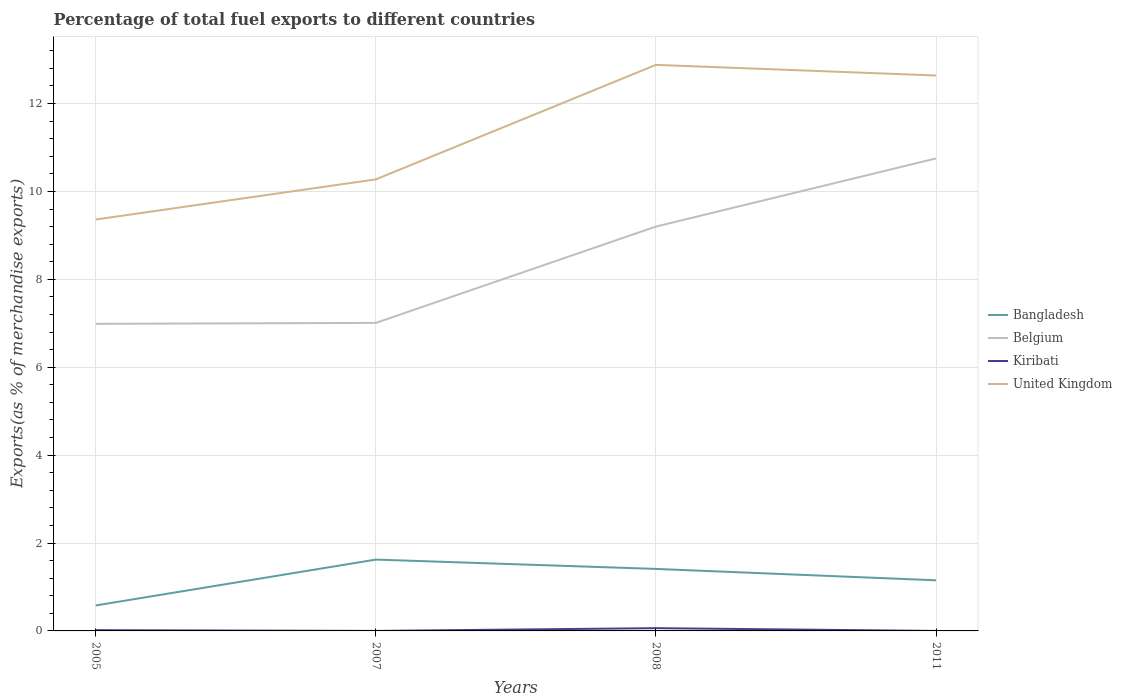How many different coloured lines are there?
Ensure brevity in your answer.  4. Is the number of lines equal to the number of legend labels?
Your answer should be compact. Yes. Across all years, what is the maximum percentage of exports to different countries in Bangladesh?
Your answer should be very brief. 0.58. What is the total percentage of exports to different countries in United Kingdom in the graph?
Your answer should be compact. -3.52. What is the difference between the highest and the second highest percentage of exports to different countries in Kiribati?
Ensure brevity in your answer.  0.06. What is the difference between the highest and the lowest percentage of exports to different countries in Bangladesh?
Your response must be concise. 2. How many lines are there?
Your answer should be very brief. 4. How many years are there in the graph?
Make the answer very short. 4. Are the values on the major ticks of Y-axis written in scientific E-notation?
Keep it short and to the point. No. Does the graph contain grids?
Give a very brief answer. Yes. What is the title of the graph?
Provide a succinct answer. Percentage of total fuel exports to different countries. What is the label or title of the Y-axis?
Provide a short and direct response. Exports(as % of merchandise exports). What is the Exports(as % of merchandise exports) in Bangladesh in 2005?
Your response must be concise. 0.58. What is the Exports(as % of merchandise exports) of Belgium in 2005?
Make the answer very short. 6.99. What is the Exports(as % of merchandise exports) of Kiribati in 2005?
Give a very brief answer. 0.02. What is the Exports(as % of merchandise exports) of United Kingdom in 2005?
Your answer should be very brief. 9.36. What is the Exports(as % of merchandise exports) of Bangladesh in 2007?
Your answer should be very brief. 1.62. What is the Exports(as % of merchandise exports) of Belgium in 2007?
Offer a very short reply. 7.01. What is the Exports(as % of merchandise exports) of Kiribati in 2007?
Offer a terse response. 0. What is the Exports(as % of merchandise exports) in United Kingdom in 2007?
Ensure brevity in your answer.  10.27. What is the Exports(as % of merchandise exports) of Bangladesh in 2008?
Offer a very short reply. 1.41. What is the Exports(as % of merchandise exports) in Belgium in 2008?
Your answer should be compact. 9.2. What is the Exports(as % of merchandise exports) in Kiribati in 2008?
Provide a succinct answer. 0.06. What is the Exports(as % of merchandise exports) of United Kingdom in 2008?
Your answer should be very brief. 12.88. What is the Exports(as % of merchandise exports) of Bangladesh in 2011?
Provide a succinct answer. 1.15. What is the Exports(as % of merchandise exports) in Belgium in 2011?
Provide a short and direct response. 10.75. What is the Exports(as % of merchandise exports) in Kiribati in 2011?
Ensure brevity in your answer.  0. What is the Exports(as % of merchandise exports) in United Kingdom in 2011?
Make the answer very short. 12.64. Across all years, what is the maximum Exports(as % of merchandise exports) in Bangladesh?
Your answer should be compact. 1.62. Across all years, what is the maximum Exports(as % of merchandise exports) in Belgium?
Your response must be concise. 10.75. Across all years, what is the maximum Exports(as % of merchandise exports) of Kiribati?
Keep it short and to the point. 0.06. Across all years, what is the maximum Exports(as % of merchandise exports) of United Kingdom?
Provide a short and direct response. 12.88. Across all years, what is the minimum Exports(as % of merchandise exports) in Bangladesh?
Give a very brief answer. 0.58. Across all years, what is the minimum Exports(as % of merchandise exports) of Belgium?
Give a very brief answer. 6.99. Across all years, what is the minimum Exports(as % of merchandise exports) of Kiribati?
Ensure brevity in your answer.  0. Across all years, what is the minimum Exports(as % of merchandise exports) in United Kingdom?
Ensure brevity in your answer.  9.36. What is the total Exports(as % of merchandise exports) in Bangladesh in the graph?
Give a very brief answer. 4.77. What is the total Exports(as % of merchandise exports) of Belgium in the graph?
Offer a very short reply. 33.95. What is the total Exports(as % of merchandise exports) of Kiribati in the graph?
Ensure brevity in your answer.  0.08. What is the total Exports(as % of merchandise exports) of United Kingdom in the graph?
Give a very brief answer. 45.15. What is the difference between the Exports(as % of merchandise exports) in Bangladesh in 2005 and that in 2007?
Offer a very short reply. -1.04. What is the difference between the Exports(as % of merchandise exports) of Belgium in 2005 and that in 2007?
Your answer should be very brief. -0.02. What is the difference between the Exports(as % of merchandise exports) of Kiribati in 2005 and that in 2007?
Your answer should be very brief. 0.02. What is the difference between the Exports(as % of merchandise exports) of United Kingdom in 2005 and that in 2007?
Offer a terse response. -0.91. What is the difference between the Exports(as % of merchandise exports) of Bangladesh in 2005 and that in 2008?
Offer a very short reply. -0.83. What is the difference between the Exports(as % of merchandise exports) in Belgium in 2005 and that in 2008?
Provide a succinct answer. -2.21. What is the difference between the Exports(as % of merchandise exports) of Kiribati in 2005 and that in 2008?
Your answer should be very brief. -0.05. What is the difference between the Exports(as % of merchandise exports) of United Kingdom in 2005 and that in 2008?
Your answer should be compact. -3.52. What is the difference between the Exports(as % of merchandise exports) in Bangladesh in 2005 and that in 2011?
Your answer should be very brief. -0.57. What is the difference between the Exports(as % of merchandise exports) of Belgium in 2005 and that in 2011?
Provide a short and direct response. -3.76. What is the difference between the Exports(as % of merchandise exports) in Kiribati in 2005 and that in 2011?
Offer a very short reply. 0.02. What is the difference between the Exports(as % of merchandise exports) of United Kingdom in 2005 and that in 2011?
Keep it short and to the point. -3.28. What is the difference between the Exports(as % of merchandise exports) in Bangladesh in 2007 and that in 2008?
Your answer should be compact. 0.21. What is the difference between the Exports(as % of merchandise exports) of Belgium in 2007 and that in 2008?
Your response must be concise. -2.19. What is the difference between the Exports(as % of merchandise exports) of Kiribati in 2007 and that in 2008?
Your response must be concise. -0.06. What is the difference between the Exports(as % of merchandise exports) of United Kingdom in 2007 and that in 2008?
Ensure brevity in your answer.  -2.61. What is the difference between the Exports(as % of merchandise exports) of Bangladesh in 2007 and that in 2011?
Offer a very short reply. 0.47. What is the difference between the Exports(as % of merchandise exports) of Belgium in 2007 and that in 2011?
Offer a terse response. -3.74. What is the difference between the Exports(as % of merchandise exports) of Kiribati in 2007 and that in 2011?
Provide a succinct answer. 0. What is the difference between the Exports(as % of merchandise exports) in United Kingdom in 2007 and that in 2011?
Provide a short and direct response. -2.36. What is the difference between the Exports(as % of merchandise exports) in Bangladesh in 2008 and that in 2011?
Offer a very short reply. 0.26. What is the difference between the Exports(as % of merchandise exports) in Belgium in 2008 and that in 2011?
Your answer should be very brief. -1.55. What is the difference between the Exports(as % of merchandise exports) of Kiribati in 2008 and that in 2011?
Provide a short and direct response. 0.06. What is the difference between the Exports(as % of merchandise exports) of United Kingdom in 2008 and that in 2011?
Offer a terse response. 0.24. What is the difference between the Exports(as % of merchandise exports) of Bangladesh in 2005 and the Exports(as % of merchandise exports) of Belgium in 2007?
Ensure brevity in your answer.  -6.43. What is the difference between the Exports(as % of merchandise exports) of Bangladesh in 2005 and the Exports(as % of merchandise exports) of Kiribati in 2007?
Ensure brevity in your answer.  0.58. What is the difference between the Exports(as % of merchandise exports) in Bangladesh in 2005 and the Exports(as % of merchandise exports) in United Kingdom in 2007?
Offer a very short reply. -9.7. What is the difference between the Exports(as % of merchandise exports) of Belgium in 2005 and the Exports(as % of merchandise exports) of Kiribati in 2007?
Give a very brief answer. 6.99. What is the difference between the Exports(as % of merchandise exports) of Belgium in 2005 and the Exports(as % of merchandise exports) of United Kingdom in 2007?
Make the answer very short. -3.29. What is the difference between the Exports(as % of merchandise exports) of Kiribati in 2005 and the Exports(as % of merchandise exports) of United Kingdom in 2007?
Your response must be concise. -10.26. What is the difference between the Exports(as % of merchandise exports) in Bangladesh in 2005 and the Exports(as % of merchandise exports) in Belgium in 2008?
Keep it short and to the point. -8.62. What is the difference between the Exports(as % of merchandise exports) of Bangladesh in 2005 and the Exports(as % of merchandise exports) of Kiribati in 2008?
Offer a very short reply. 0.52. What is the difference between the Exports(as % of merchandise exports) in Bangladesh in 2005 and the Exports(as % of merchandise exports) in United Kingdom in 2008?
Keep it short and to the point. -12.3. What is the difference between the Exports(as % of merchandise exports) of Belgium in 2005 and the Exports(as % of merchandise exports) of Kiribati in 2008?
Provide a succinct answer. 6.92. What is the difference between the Exports(as % of merchandise exports) in Belgium in 2005 and the Exports(as % of merchandise exports) in United Kingdom in 2008?
Give a very brief answer. -5.89. What is the difference between the Exports(as % of merchandise exports) of Kiribati in 2005 and the Exports(as % of merchandise exports) of United Kingdom in 2008?
Ensure brevity in your answer.  -12.86. What is the difference between the Exports(as % of merchandise exports) in Bangladesh in 2005 and the Exports(as % of merchandise exports) in Belgium in 2011?
Your answer should be very brief. -10.17. What is the difference between the Exports(as % of merchandise exports) in Bangladesh in 2005 and the Exports(as % of merchandise exports) in Kiribati in 2011?
Ensure brevity in your answer.  0.58. What is the difference between the Exports(as % of merchandise exports) in Bangladesh in 2005 and the Exports(as % of merchandise exports) in United Kingdom in 2011?
Your response must be concise. -12.06. What is the difference between the Exports(as % of merchandise exports) in Belgium in 2005 and the Exports(as % of merchandise exports) in Kiribati in 2011?
Provide a succinct answer. 6.99. What is the difference between the Exports(as % of merchandise exports) in Belgium in 2005 and the Exports(as % of merchandise exports) in United Kingdom in 2011?
Offer a very short reply. -5.65. What is the difference between the Exports(as % of merchandise exports) of Kiribati in 2005 and the Exports(as % of merchandise exports) of United Kingdom in 2011?
Your response must be concise. -12.62. What is the difference between the Exports(as % of merchandise exports) in Bangladesh in 2007 and the Exports(as % of merchandise exports) in Belgium in 2008?
Your answer should be very brief. -7.58. What is the difference between the Exports(as % of merchandise exports) of Bangladesh in 2007 and the Exports(as % of merchandise exports) of Kiribati in 2008?
Provide a short and direct response. 1.56. What is the difference between the Exports(as % of merchandise exports) in Bangladesh in 2007 and the Exports(as % of merchandise exports) in United Kingdom in 2008?
Keep it short and to the point. -11.26. What is the difference between the Exports(as % of merchandise exports) of Belgium in 2007 and the Exports(as % of merchandise exports) of Kiribati in 2008?
Provide a succinct answer. 6.95. What is the difference between the Exports(as % of merchandise exports) of Belgium in 2007 and the Exports(as % of merchandise exports) of United Kingdom in 2008?
Your answer should be very brief. -5.87. What is the difference between the Exports(as % of merchandise exports) in Kiribati in 2007 and the Exports(as % of merchandise exports) in United Kingdom in 2008?
Make the answer very short. -12.88. What is the difference between the Exports(as % of merchandise exports) in Bangladesh in 2007 and the Exports(as % of merchandise exports) in Belgium in 2011?
Your answer should be compact. -9.13. What is the difference between the Exports(as % of merchandise exports) of Bangladesh in 2007 and the Exports(as % of merchandise exports) of Kiribati in 2011?
Keep it short and to the point. 1.62. What is the difference between the Exports(as % of merchandise exports) in Bangladesh in 2007 and the Exports(as % of merchandise exports) in United Kingdom in 2011?
Provide a succinct answer. -11.02. What is the difference between the Exports(as % of merchandise exports) of Belgium in 2007 and the Exports(as % of merchandise exports) of Kiribati in 2011?
Give a very brief answer. 7.01. What is the difference between the Exports(as % of merchandise exports) of Belgium in 2007 and the Exports(as % of merchandise exports) of United Kingdom in 2011?
Offer a terse response. -5.63. What is the difference between the Exports(as % of merchandise exports) in Kiribati in 2007 and the Exports(as % of merchandise exports) in United Kingdom in 2011?
Offer a terse response. -12.64. What is the difference between the Exports(as % of merchandise exports) in Bangladesh in 2008 and the Exports(as % of merchandise exports) in Belgium in 2011?
Offer a terse response. -9.34. What is the difference between the Exports(as % of merchandise exports) of Bangladesh in 2008 and the Exports(as % of merchandise exports) of Kiribati in 2011?
Give a very brief answer. 1.41. What is the difference between the Exports(as % of merchandise exports) in Bangladesh in 2008 and the Exports(as % of merchandise exports) in United Kingdom in 2011?
Your answer should be compact. -11.23. What is the difference between the Exports(as % of merchandise exports) in Belgium in 2008 and the Exports(as % of merchandise exports) in Kiribati in 2011?
Your answer should be very brief. 9.2. What is the difference between the Exports(as % of merchandise exports) of Belgium in 2008 and the Exports(as % of merchandise exports) of United Kingdom in 2011?
Make the answer very short. -3.44. What is the difference between the Exports(as % of merchandise exports) in Kiribati in 2008 and the Exports(as % of merchandise exports) in United Kingdom in 2011?
Ensure brevity in your answer.  -12.58. What is the average Exports(as % of merchandise exports) in Bangladesh per year?
Your response must be concise. 1.19. What is the average Exports(as % of merchandise exports) of Belgium per year?
Your answer should be very brief. 8.49. What is the average Exports(as % of merchandise exports) in Kiribati per year?
Provide a succinct answer. 0.02. What is the average Exports(as % of merchandise exports) of United Kingdom per year?
Give a very brief answer. 11.29. In the year 2005, what is the difference between the Exports(as % of merchandise exports) of Bangladesh and Exports(as % of merchandise exports) of Belgium?
Keep it short and to the point. -6.41. In the year 2005, what is the difference between the Exports(as % of merchandise exports) of Bangladesh and Exports(as % of merchandise exports) of Kiribati?
Your answer should be compact. 0.56. In the year 2005, what is the difference between the Exports(as % of merchandise exports) of Bangladesh and Exports(as % of merchandise exports) of United Kingdom?
Ensure brevity in your answer.  -8.78. In the year 2005, what is the difference between the Exports(as % of merchandise exports) in Belgium and Exports(as % of merchandise exports) in Kiribati?
Provide a short and direct response. 6.97. In the year 2005, what is the difference between the Exports(as % of merchandise exports) in Belgium and Exports(as % of merchandise exports) in United Kingdom?
Provide a succinct answer. -2.37. In the year 2005, what is the difference between the Exports(as % of merchandise exports) of Kiribati and Exports(as % of merchandise exports) of United Kingdom?
Offer a terse response. -9.34. In the year 2007, what is the difference between the Exports(as % of merchandise exports) in Bangladesh and Exports(as % of merchandise exports) in Belgium?
Provide a succinct answer. -5.39. In the year 2007, what is the difference between the Exports(as % of merchandise exports) of Bangladesh and Exports(as % of merchandise exports) of Kiribati?
Make the answer very short. 1.62. In the year 2007, what is the difference between the Exports(as % of merchandise exports) of Bangladesh and Exports(as % of merchandise exports) of United Kingdom?
Provide a short and direct response. -8.65. In the year 2007, what is the difference between the Exports(as % of merchandise exports) of Belgium and Exports(as % of merchandise exports) of Kiribati?
Your answer should be very brief. 7.01. In the year 2007, what is the difference between the Exports(as % of merchandise exports) of Belgium and Exports(as % of merchandise exports) of United Kingdom?
Offer a very short reply. -3.27. In the year 2007, what is the difference between the Exports(as % of merchandise exports) in Kiribati and Exports(as % of merchandise exports) in United Kingdom?
Make the answer very short. -10.27. In the year 2008, what is the difference between the Exports(as % of merchandise exports) in Bangladesh and Exports(as % of merchandise exports) in Belgium?
Offer a terse response. -7.79. In the year 2008, what is the difference between the Exports(as % of merchandise exports) of Bangladesh and Exports(as % of merchandise exports) of Kiribati?
Offer a very short reply. 1.35. In the year 2008, what is the difference between the Exports(as % of merchandise exports) in Bangladesh and Exports(as % of merchandise exports) in United Kingdom?
Your answer should be very brief. -11.47. In the year 2008, what is the difference between the Exports(as % of merchandise exports) in Belgium and Exports(as % of merchandise exports) in Kiribati?
Your answer should be very brief. 9.14. In the year 2008, what is the difference between the Exports(as % of merchandise exports) in Belgium and Exports(as % of merchandise exports) in United Kingdom?
Your answer should be very brief. -3.68. In the year 2008, what is the difference between the Exports(as % of merchandise exports) of Kiribati and Exports(as % of merchandise exports) of United Kingdom?
Provide a short and direct response. -12.82. In the year 2011, what is the difference between the Exports(as % of merchandise exports) in Bangladesh and Exports(as % of merchandise exports) in Belgium?
Your answer should be very brief. -9.6. In the year 2011, what is the difference between the Exports(as % of merchandise exports) of Bangladesh and Exports(as % of merchandise exports) of Kiribati?
Make the answer very short. 1.15. In the year 2011, what is the difference between the Exports(as % of merchandise exports) in Bangladesh and Exports(as % of merchandise exports) in United Kingdom?
Provide a short and direct response. -11.49. In the year 2011, what is the difference between the Exports(as % of merchandise exports) of Belgium and Exports(as % of merchandise exports) of Kiribati?
Offer a terse response. 10.75. In the year 2011, what is the difference between the Exports(as % of merchandise exports) in Belgium and Exports(as % of merchandise exports) in United Kingdom?
Make the answer very short. -1.89. In the year 2011, what is the difference between the Exports(as % of merchandise exports) in Kiribati and Exports(as % of merchandise exports) in United Kingdom?
Your response must be concise. -12.64. What is the ratio of the Exports(as % of merchandise exports) of Bangladesh in 2005 to that in 2007?
Ensure brevity in your answer.  0.36. What is the ratio of the Exports(as % of merchandise exports) of Kiribati in 2005 to that in 2007?
Offer a terse response. 69.38. What is the ratio of the Exports(as % of merchandise exports) in United Kingdom in 2005 to that in 2007?
Your answer should be very brief. 0.91. What is the ratio of the Exports(as % of merchandise exports) of Bangladesh in 2005 to that in 2008?
Your response must be concise. 0.41. What is the ratio of the Exports(as % of merchandise exports) of Belgium in 2005 to that in 2008?
Give a very brief answer. 0.76. What is the ratio of the Exports(as % of merchandise exports) of Kiribati in 2005 to that in 2008?
Keep it short and to the point. 0.27. What is the ratio of the Exports(as % of merchandise exports) of United Kingdom in 2005 to that in 2008?
Provide a succinct answer. 0.73. What is the ratio of the Exports(as % of merchandise exports) in Bangladesh in 2005 to that in 2011?
Your answer should be compact. 0.5. What is the ratio of the Exports(as % of merchandise exports) of Belgium in 2005 to that in 2011?
Keep it short and to the point. 0.65. What is the ratio of the Exports(as % of merchandise exports) in Kiribati in 2005 to that in 2011?
Provide a short and direct response. 147.01. What is the ratio of the Exports(as % of merchandise exports) in United Kingdom in 2005 to that in 2011?
Ensure brevity in your answer.  0.74. What is the ratio of the Exports(as % of merchandise exports) of Bangladesh in 2007 to that in 2008?
Offer a very short reply. 1.15. What is the ratio of the Exports(as % of merchandise exports) of Belgium in 2007 to that in 2008?
Give a very brief answer. 0.76. What is the ratio of the Exports(as % of merchandise exports) of Kiribati in 2007 to that in 2008?
Provide a succinct answer. 0. What is the ratio of the Exports(as % of merchandise exports) in United Kingdom in 2007 to that in 2008?
Ensure brevity in your answer.  0.8. What is the ratio of the Exports(as % of merchandise exports) in Bangladesh in 2007 to that in 2011?
Offer a terse response. 1.41. What is the ratio of the Exports(as % of merchandise exports) of Belgium in 2007 to that in 2011?
Give a very brief answer. 0.65. What is the ratio of the Exports(as % of merchandise exports) in Kiribati in 2007 to that in 2011?
Give a very brief answer. 2.12. What is the ratio of the Exports(as % of merchandise exports) of United Kingdom in 2007 to that in 2011?
Offer a very short reply. 0.81. What is the ratio of the Exports(as % of merchandise exports) of Bangladesh in 2008 to that in 2011?
Your answer should be compact. 1.22. What is the ratio of the Exports(as % of merchandise exports) of Belgium in 2008 to that in 2011?
Provide a succinct answer. 0.86. What is the ratio of the Exports(as % of merchandise exports) of Kiribati in 2008 to that in 2011?
Give a very brief answer. 540.83. What is the ratio of the Exports(as % of merchandise exports) of United Kingdom in 2008 to that in 2011?
Offer a very short reply. 1.02. What is the difference between the highest and the second highest Exports(as % of merchandise exports) of Bangladesh?
Your answer should be very brief. 0.21. What is the difference between the highest and the second highest Exports(as % of merchandise exports) of Belgium?
Keep it short and to the point. 1.55. What is the difference between the highest and the second highest Exports(as % of merchandise exports) of Kiribati?
Your response must be concise. 0.05. What is the difference between the highest and the second highest Exports(as % of merchandise exports) in United Kingdom?
Keep it short and to the point. 0.24. What is the difference between the highest and the lowest Exports(as % of merchandise exports) in Bangladesh?
Keep it short and to the point. 1.04. What is the difference between the highest and the lowest Exports(as % of merchandise exports) in Belgium?
Give a very brief answer. 3.76. What is the difference between the highest and the lowest Exports(as % of merchandise exports) of Kiribati?
Your answer should be compact. 0.06. What is the difference between the highest and the lowest Exports(as % of merchandise exports) of United Kingdom?
Your answer should be very brief. 3.52. 